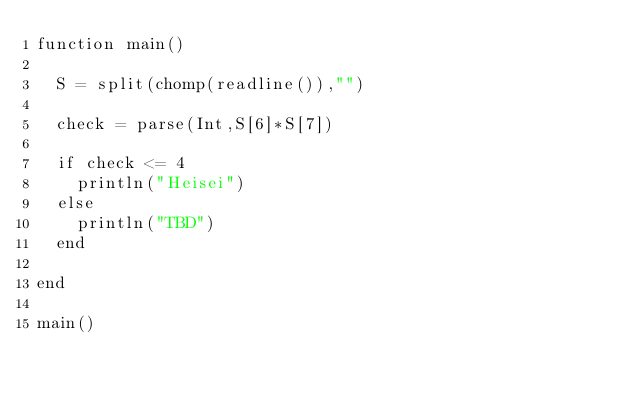<code> <loc_0><loc_0><loc_500><loc_500><_Julia_>function main()
  
  S = split(chomp(readline()),"")
  
  check = parse(Int,S[6]*S[7])
  
  if check <= 4
    println("Heisei")
  else
    println("TBD")
  end
  
end

main()</code> 